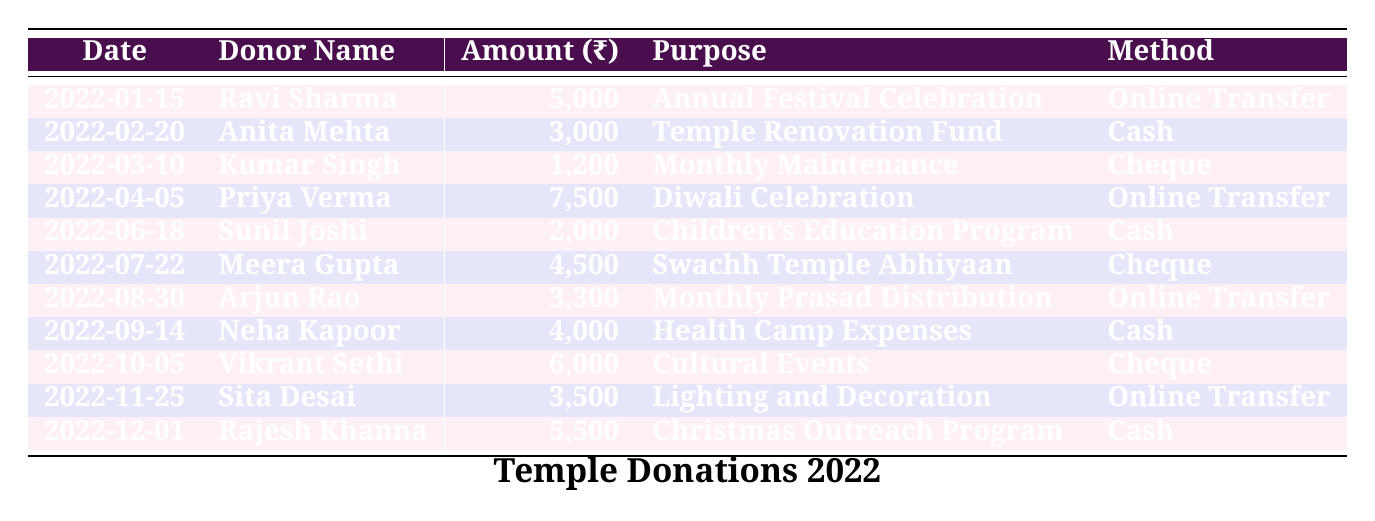What is the total amount of donations received in January 2022? From the table, there is one donation in January from Ravi Sharma for ₹5,000. Thus, the total amount in January is ₹5,000.
Answer: ₹5,000 Who donated the most for the Diwali Celebration? Priya Verma donated ₹7,500 for the Diwali Celebration, which is indicated in the purpose column.
Answer: Priya Verma How many donations were made through cash? From the table, there are four donations made using cash: Anita Mehta (₹3,000), Sunil Joshi (₹2,000), Neha Kapoor (₹4,000), and Rajesh Khanna (₹5,500). Thus, there are 4 cash donations.
Answer: 4 What is the average amount donated for the Cultural Events? Vikrant Sethi is the only donor listed for Cultural Events with a contribution of ₹6,000, hence the average donation is ₹6,000/1 = ₹6,000.
Answer: ₹6,000 Did any donor contribute to more than one purpose? Reviewing the table, all donors contributed to a unique purpose; therefore, no donor donated for more than one purpose.
Answer: No What purpose received the highest total donation amount? The amounts for each purpose are summed up: Annual Festival Celebration (₹5,000), Temple Renovation Fund (₹3,000), Monthly Maintenance (₹1,200), Diwali Celebration (₹7,500), Children's Education Program (₹2,000), Swachh Temple Abhiyaan (₹4,500), Monthly Prasad Distribution (₹3,300), Health Camp Expenses (₹4,000), Cultural Events (₹6,000), Lighting and Decoration (₹3,500), Christmas Outreach Program (₹5,500). The highest total is for the Diwali Celebration at ₹7,500.
Answer: Diwali Celebration Which donation method had the highest total donation amount? Analyzing the donation methods: Online Transfer contributed ₹14,800 (₹5,000 + ₹7,500 + ₹3,300 + ₹3,500), Cash contributed ₹14,500 (₹3,000 + ₹2,000 + ₹4,000 + ₹5,500), and Cheque contributed ₹11,700 (₹1,200 + ₹4,500 + ₹6,000). Online Transfer has the highest total amount.
Answer: Online Transfer What is the difference between the highest and lowest donation amounts? The highest donation is ₹7,500 (Diwali Celebration) and the lowest is ₹1,200 (Monthly Maintenance), so the difference is ₹7,500 - ₹1,200 = ₹6,300.
Answer: ₹6,300 Who made the last donation of the year, and what was the amount? The last donation of the year, recorded on December 1, 2022, was made by Rajesh Khanna, who donated ₹5,500.
Answer: Rajesh Khanna, ₹5,500 What percentage of total donations were made for the Children's Education Program? The total amount of donations is ₹5,000 + ₹3,000 + ₹1,200 + ₹7,500 + ₹2,000 + ₹4,500 + ₹3,300 + ₹4,000 + ₹6,000 + ₹3,500 + ₹5,500 = ₹45,000. The donation for Children’s Education Program is ₹2,000, so the percentage is (₹2,000/₹45,000) * 100 = 4.44%.
Answer: 4.44% 